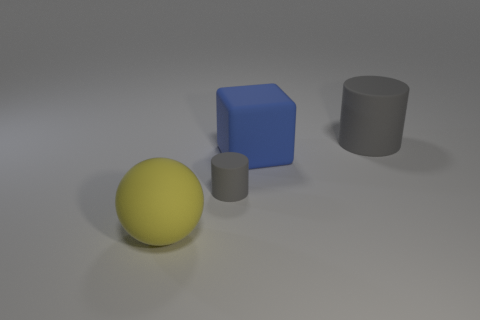Add 1 small gray matte cylinders. How many objects exist? 5 Subtract all balls. How many objects are left? 3 Subtract 2 gray cylinders. How many objects are left? 2 Subtract all big gray objects. Subtract all big yellow things. How many objects are left? 2 Add 1 big blue blocks. How many big blue blocks are left? 2 Add 1 big green things. How many big green things exist? 1 